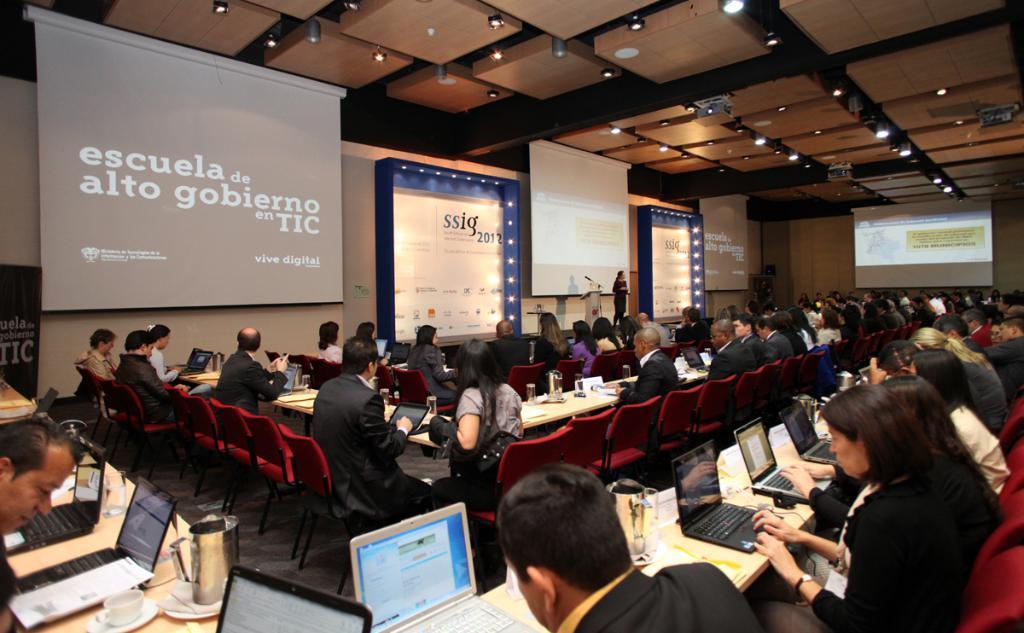Please provide a concise description of this image. In this image there are group of people sitting on the chairs, there are jugs, laptops, glasses and some other objects on the tables, and in the background there is a person standing on the stage near the podium, and there are projectors, screens and lights. 